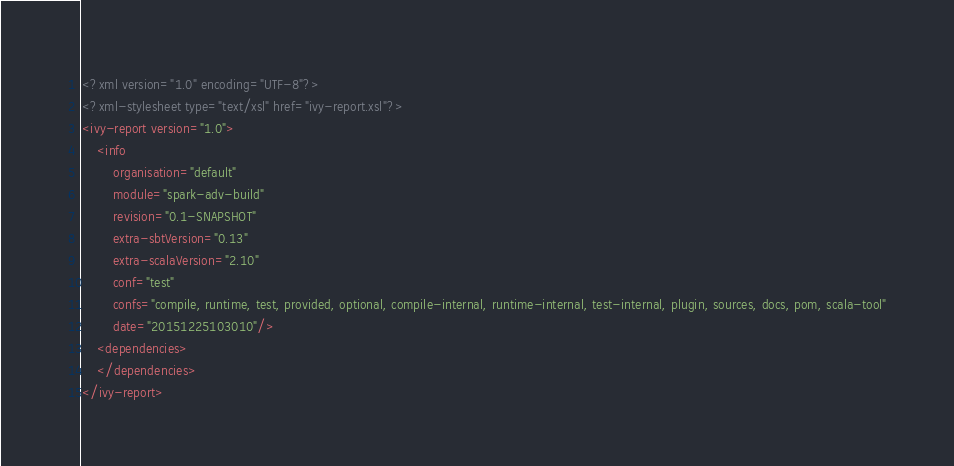<code> <loc_0><loc_0><loc_500><loc_500><_XML_><?xml version="1.0" encoding="UTF-8"?>
<?xml-stylesheet type="text/xsl" href="ivy-report.xsl"?>
<ivy-report version="1.0">
	<info
		organisation="default"
		module="spark-adv-build"
		revision="0.1-SNAPSHOT"
		extra-sbtVersion="0.13"
		extra-scalaVersion="2.10"
		conf="test"
		confs="compile, runtime, test, provided, optional, compile-internal, runtime-internal, test-internal, plugin, sources, docs, pom, scala-tool"
		date="20151225103010"/>
	<dependencies>
	</dependencies>
</ivy-report>
</code> 